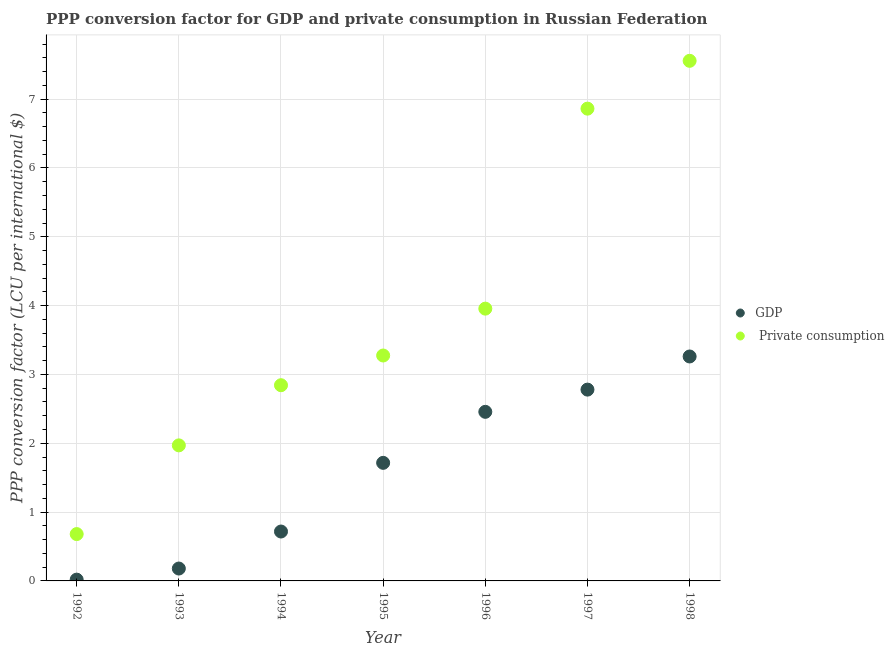How many different coloured dotlines are there?
Offer a very short reply. 2. What is the ppp conversion factor for private consumption in 1993?
Your answer should be very brief. 1.97. Across all years, what is the maximum ppp conversion factor for gdp?
Your response must be concise. 3.26. Across all years, what is the minimum ppp conversion factor for private consumption?
Make the answer very short. 0.68. In which year was the ppp conversion factor for private consumption maximum?
Your answer should be very brief. 1998. In which year was the ppp conversion factor for gdp minimum?
Provide a short and direct response. 1992. What is the total ppp conversion factor for gdp in the graph?
Offer a very short reply. 11.13. What is the difference between the ppp conversion factor for gdp in 1993 and that in 1998?
Your answer should be compact. -3.08. What is the difference between the ppp conversion factor for private consumption in 1997 and the ppp conversion factor for gdp in 1995?
Offer a terse response. 5.15. What is the average ppp conversion factor for gdp per year?
Make the answer very short. 1.59. In the year 1995, what is the difference between the ppp conversion factor for gdp and ppp conversion factor for private consumption?
Offer a very short reply. -1.56. What is the ratio of the ppp conversion factor for gdp in 1994 to that in 1998?
Keep it short and to the point. 0.22. Is the difference between the ppp conversion factor for gdp in 1992 and 1996 greater than the difference between the ppp conversion factor for private consumption in 1992 and 1996?
Offer a terse response. Yes. What is the difference between the highest and the second highest ppp conversion factor for private consumption?
Offer a terse response. 0.69. What is the difference between the highest and the lowest ppp conversion factor for private consumption?
Give a very brief answer. 6.88. Is the ppp conversion factor for private consumption strictly less than the ppp conversion factor for gdp over the years?
Your answer should be compact. No. How many dotlines are there?
Make the answer very short. 2. Does the graph contain any zero values?
Your answer should be very brief. No. Does the graph contain grids?
Make the answer very short. Yes. What is the title of the graph?
Give a very brief answer. PPP conversion factor for GDP and private consumption in Russian Federation. Does "Official aid received" appear as one of the legend labels in the graph?
Your answer should be very brief. No. What is the label or title of the Y-axis?
Your answer should be very brief. PPP conversion factor (LCU per international $). What is the PPP conversion factor (LCU per international $) in GDP in 1992?
Your response must be concise. 0.02. What is the PPP conversion factor (LCU per international $) in  Private consumption in 1992?
Your response must be concise. 0.68. What is the PPP conversion factor (LCU per international $) of GDP in 1993?
Keep it short and to the point. 0.18. What is the PPP conversion factor (LCU per international $) in  Private consumption in 1993?
Provide a succinct answer. 1.97. What is the PPP conversion factor (LCU per international $) of GDP in 1994?
Make the answer very short. 0.72. What is the PPP conversion factor (LCU per international $) in  Private consumption in 1994?
Give a very brief answer. 2.84. What is the PPP conversion factor (LCU per international $) of GDP in 1995?
Provide a succinct answer. 1.72. What is the PPP conversion factor (LCU per international $) in  Private consumption in 1995?
Offer a terse response. 3.28. What is the PPP conversion factor (LCU per international $) of GDP in 1996?
Offer a very short reply. 2.46. What is the PPP conversion factor (LCU per international $) of  Private consumption in 1996?
Offer a terse response. 3.96. What is the PPP conversion factor (LCU per international $) in GDP in 1997?
Offer a very short reply. 2.78. What is the PPP conversion factor (LCU per international $) in  Private consumption in 1997?
Your response must be concise. 6.86. What is the PPP conversion factor (LCU per international $) of GDP in 1998?
Keep it short and to the point. 3.26. What is the PPP conversion factor (LCU per international $) of  Private consumption in 1998?
Offer a terse response. 7.56. Across all years, what is the maximum PPP conversion factor (LCU per international $) of GDP?
Your answer should be very brief. 3.26. Across all years, what is the maximum PPP conversion factor (LCU per international $) of  Private consumption?
Give a very brief answer. 7.56. Across all years, what is the minimum PPP conversion factor (LCU per international $) of GDP?
Ensure brevity in your answer.  0.02. Across all years, what is the minimum PPP conversion factor (LCU per international $) of  Private consumption?
Your answer should be very brief. 0.68. What is the total PPP conversion factor (LCU per international $) in GDP in the graph?
Ensure brevity in your answer.  11.13. What is the total PPP conversion factor (LCU per international $) in  Private consumption in the graph?
Your response must be concise. 27.14. What is the difference between the PPP conversion factor (LCU per international $) of GDP in 1992 and that in 1993?
Your response must be concise. -0.16. What is the difference between the PPP conversion factor (LCU per international $) in  Private consumption in 1992 and that in 1993?
Your response must be concise. -1.29. What is the difference between the PPP conversion factor (LCU per international $) of GDP in 1992 and that in 1994?
Keep it short and to the point. -0.7. What is the difference between the PPP conversion factor (LCU per international $) in  Private consumption in 1992 and that in 1994?
Offer a very short reply. -2.16. What is the difference between the PPP conversion factor (LCU per international $) in GDP in 1992 and that in 1995?
Ensure brevity in your answer.  -1.7. What is the difference between the PPP conversion factor (LCU per international $) in  Private consumption in 1992 and that in 1995?
Provide a succinct answer. -2.59. What is the difference between the PPP conversion factor (LCU per international $) in GDP in 1992 and that in 1996?
Provide a succinct answer. -2.44. What is the difference between the PPP conversion factor (LCU per international $) in  Private consumption in 1992 and that in 1996?
Ensure brevity in your answer.  -3.28. What is the difference between the PPP conversion factor (LCU per international $) of GDP in 1992 and that in 1997?
Give a very brief answer. -2.76. What is the difference between the PPP conversion factor (LCU per international $) of  Private consumption in 1992 and that in 1997?
Offer a terse response. -6.18. What is the difference between the PPP conversion factor (LCU per international $) in GDP in 1992 and that in 1998?
Give a very brief answer. -3.24. What is the difference between the PPP conversion factor (LCU per international $) in  Private consumption in 1992 and that in 1998?
Your answer should be compact. -6.88. What is the difference between the PPP conversion factor (LCU per international $) in GDP in 1993 and that in 1994?
Your answer should be very brief. -0.54. What is the difference between the PPP conversion factor (LCU per international $) in  Private consumption in 1993 and that in 1994?
Give a very brief answer. -0.87. What is the difference between the PPP conversion factor (LCU per international $) in GDP in 1993 and that in 1995?
Give a very brief answer. -1.54. What is the difference between the PPP conversion factor (LCU per international $) of  Private consumption in 1993 and that in 1995?
Offer a very short reply. -1.31. What is the difference between the PPP conversion factor (LCU per international $) in GDP in 1993 and that in 1996?
Provide a succinct answer. -2.28. What is the difference between the PPP conversion factor (LCU per international $) of  Private consumption in 1993 and that in 1996?
Ensure brevity in your answer.  -1.99. What is the difference between the PPP conversion factor (LCU per international $) in GDP in 1993 and that in 1997?
Offer a very short reply. -2.6. What is the difference between the PPP conversion factor (LCU per international $) in  Private consumption in 1993 and that in 1997?
Your answer should be compact. -4.89. What is the difference between the PPP conversion factor (LCU per international $) in GDP in 1993 and that in 1998?
Provide a short and direct response. -3.08. What is the difference between the PPP conversion factor (LCU per international $) of  Private consumption in 1993 and that in 1998?
Your response must be concise. -5.59. What is the difference between the PPP conversion factor (LCU per international $) in GDP in 1994 and that in 1995?
Provide a short and direct response. -1. What is the difference between the PPP conversion factor (LCU per international $) of  Private consumption in 1994 and that in 1995?
Ensure brevity in your answer.  -0.43. What is the difference between the PPP conversion factor (LCU per international $) in GDP in 1994 and that in 1996?
Your answer should be very brief. -1.74. What is the difference between the PPP conversion factor (LCU per international $) of  Private consumption in 1994 and that in 1996?
Keep it short and to the point. -1.11. What is the difference between the PPP conversion factor (LCU per international $) of GDP in 1994 and that in 1997?
Ensure brevity in your answer.  -2.06. What is the difference between the PPP conversion factor (LCU per international $) of  Private consumption in 1994 and that in 1997?
Your answer should be very brief. -4.02. What is the difference between the PPP conversion factor (LCU per international $) in GDP in 1994 and that in 1998?
Your answer should be very brief. -2.54. What is the difference between the PPP conversion factor (LCU per international $) of  Private consumption in 1994 and that in 1998?
Keep it short and to the point. -4.71. What is the difference between the PPP conversion factor (LCU per international $) in GDP in 1995 and that in 1996?
Your answer should be compact. -0.74. What is the difference between the PPP conversion factor (LCU per international $) of  Private consumption in 1995 and that in 1996?
Your response must be concise. -0.68. What is the difference between the PPP conversion factor (LCU per international $) in GDP in 1995 and that in 1997?
Provide a short and direct response. -1.06. What is the difference between the PPP conversion factor (LCU per international $) in  Private consumption in 1995 and that in 1997?
Make the answer very short. -3.59. What is the difference between the PPP conversion factor (LCU per international $) of GDP in 1995 and that in 1998?
Ensure brevity in your answer.  -1.55. What is the difference between the PPP conversion factor (LCU per international $) in  Private consumption in 1995 and that in 1998?
Offer a very short reply. -4.28. What is the difference between the PPP conversion factor (LCU per international $) in GDP in 1996 and that in 1997?
Provide a short and direct response. -0.32. What is the difference between the PPP conversion factor (LCU per international $) in  Private consumption in 1996 and that in 1997?
Offer a terse response. -2.91. What is the difference between the PPP conversion factor (LCU per international $) of GDP in 1996 and that in 1998?
Offer a very short reply. -0.8. What is the difference between the PPP conversion factor (LCU per international $) in  Private consumption in 1996 and that in 1998?
Ensure brevity in your answer.  -3.6. What is the difference between the PPP conversion factor (LCU per international $) in GDP in 1997 and that in 1998?
Your answer should be compact. -0.48. What is the difference between the PPP conversion factor (LCU per international $) in  Private consumption in 1997 and that in 1998?
Your response must be concise. -0.69. What is the difference between the PPP conversion factor (LCU per international $) in GDP in 1992 and the PPP conversion factor (LCU per international $) in  Private consumption in 1993?
Give a very brief answer. -1.95. What is the difference between the PPP conversion factor (LCU per international $) of GDP in 1992 and the PPP conversion factor (LCU per international $) of  Private consumption in 1994?
Your answer should be compact. -2.82. What is the difference between the PPP conversion factor (LCU per international $) in GDP in 1992 and the PPP conversion factor (LCU per international $) in  Private consumption in 1995?
Give a very brief answer. -3.26. What is the difference between the PPP conversion factor (LCU per international $) in GDP in 1992 and the PPP conversion factor (LCU per international $) in  Private consumption in 1996?
Your answer should be compact. -3.94. What is the difference between the PPP conversion factor (LCU per international $) of GDP in 1992 and the PPP conversion factor (LCU per international $) of  Private consumption in 1997?
Your answer should be very brief. -6.84. What is the difference between the PPP conversion factor (LCU per international $) in GDP in 1992 and the PPP conversion factor (LCU per international $) in  Private consumption in 1998?
Make the answer very short. -7.54. What is the difference between the PPP conversion factor (LCU per international $) in GDP in 1993 and the PPP conversion factor (LCU per international $) in  Private consumption in 1994?
Give a very brief answer. -2.66. What is the difference between the PPP conversion factor (LCU per international $) in GDP in 1993 and the PPP conversion factor (LCU per international $) in  Private consumption in 1995?
Your answer should be compact. -3.1. What is the difference between the PPP conversion factor (LCU per international $) of GDP in 1993 and the PPP conversion factor (LCU per international $) of  Private consumption in 1996?
Provide a short and direct response. -3.78. What is the difference between the PPP conversion factor (LCU per international $) in GDP in 1993 and the PPP conversion factor (LCU per international $) in  Private consumption in 1997?
Provide a succinct answer. -6.68. What is the difference between the PPP conversion factor (LCU per international $) in GDP in 1993 and the PPP conversion factor (LCU per international $) in  Private consumption in 1998?
Offer a very short reply. -7.38. What is the difference between the PPP conversion factor (LCU per international $) in GDP in 1994 and the PPP conversion factor (LCU per international $) in  Private consumption in 1995?
Ensure brevity in your answer.  -2.56. What is the difference between the PPP conversion factor (LCU per international $) in GDP in 1994 and the PPP conversion factor (LCU per international $) in  Private consumption in 1996?
Give a very brief answer. -3.24. What is the difference between the PPP conversion factor (LCU per international $) of GDP in 1994 and the PPP conversion factor (LCU per international $) of  Private consumption in 1997?
Your response must be concise. -6.14. What is the difference between the PPP conversion factor (LCU per international $) in GDP in 1994 and the PPP conversion factor (LCU per international $) in  Private consumption in 1998?
Provide a short and direct response. -6.84. What is the difference between the PPP conversion factor (LCU per international $) of GDP in 1995 and the PPP conversion factor (LCU per international $) of  Private consumption in 1996?
Make the answer very short. -2.24. What is the difference between the PPP conversion factor (LCU per international $) in GDP in 1995 and the PPP conversion factor (LCU per international $) in  Private consumption in 1997?
Your answer should be compact. -5.15. What is the difference between the PPP conversion factor (LCU per international $) of GDP in 1995 and the PPP conversion factor (LCU per international $) of  Private consumption in 1998?
Make the answer very short. -5.84. What is the difference between the PPP conversion factor (LCU per international $) in GDP in 1996 and the PPP conversion factor (LCU per international $) in  Private consumption in 1997?
Your response must be concise. -4.41. What is the difference between the PPP conversion factor (LCU per international $) of GDP in 1996 and the PPP conversion factor (LCU per international $) of  Private consumption in 1998?
Make the answer very short. -5.1. What is the difference between the PPP conversion factor (LCU per international $) in GDP in 1997 and the PPP conversion factor (LCU per international $) in  Private consumption in 1998?
Offer a terse response. -4.78. What is the average PPP conversion factor (LCU per international $) of GDP per year?
Make the answer very short. 1.59. What is the average PPP conversion factor (LCU per international $) of  Private consumption per year?
Offer a terse response. 3.88. In the year 1992, what is the difference between the PPP conversion factor (LCU per international $) of GDP and PPP conversion factor (LCU per international $) of  Private consumption?
Ensure brevity in your answer.  -0.66. In the year 1993, what is the difference between the PPP conversion factor (LCU per international $) in GDP and PPP conversion factor (LCU per international $) in  Private consumption?
Your answer should be compact. -1.79. In the year 1994, what is the difference between the PPP conversion factor (LCU per international $) of GDP and PPP conversion factor (LCU per international $) of  Private consumption?
Ensure brevity in your answer.  -2.13. In the year 1995, what is the difference between the PPP conversion factor (LCU per international $) of GDP and PPP conversion factor (LCU per international $) of  Private consumption?
Your answer should be compact. -1.56. In the year 1996, what is the difference between the PPP conversion factor (LCU per international $) in GDP and PPP conversion factor (LCU per international $) in  Private consumption?
Your response must be concise. -1.5. In the year 1997, what is the difference between the PPP conversion factor (LCU per international $) in GDP and PPP conversion factor (LCU per international $) in  Private consumption?
Your answer should be very brief. -4.08. In the year 1998, what is the difference between the PPP conversion factor (LCU per international $) of GDP and PPP conversion factor (LCU per international $) of  Private consumption?
Your answer should be very brief. -4.3. What is the ratio of the PPP conversion factor (LCU per international $) in GDP in 1992 to that in 1993?
Provide a succinct answer. 0.1. What is the ratio of the PPP conversion factor (LCU per international $) of  Private consumption in 1992 to that in 1993?
Your response must be concise. 0.35. What is the ratio of the PPP conversion factor (LCU per international $) of GDP in 1992 to that in 1994?
Ensure brevity in your answer.  0.03. What is the ratio of the PPP conversion factor (LCU per international $) of  Private consumption in 1992 to that in 1994?
Offer a very short reply. 0.24. What is the ratio of the PPP conversion factor (LCU per international $) in GDP in 1992 to that in 1995?
Your answer should be very brief. 0.01. What is the ratio of the PPP conversion factor (LCU per international $) of  Private consumption in 1992 to that in 1995?
Keep it short and to the point. 0.21. What is the ratio of the PPP conversion factor (LCU per international $) in GDP in 1992 to that in 1996?
Ensure brevity in your answer.  0.01. What is the ratio of the PPP conversion factor (LCU per international $) of  Private consumption in 1992 to that in 1996?
Make the answer very short. 0.17. What is the ratio of the PPP conversion factor (LCU per international $) of GDP in 1992 to that in 1997?
Make the answer very short. 0.01. What is the ratio of the PPP conversion factor (LCU per international $) of  Private consumption in 1992 to that in 1997?
Your response must be concise. 0.1. What is the ratio of the PPP conversion factor (LCU per international $) in GDP in 1992 to that in 1998?
Offer a terse response. 0.01. What is the ratio of the PPP conversion factor (LCU per international $) in  Private consumption in 1992 to that in 1998?
Make the answer very short. 0.09. What is the ratio of the PPP conversion factor (LCU per international $) of GDP in 1993 to that in 1994?
Offer a terse response. 0.25. What is the ratio of the PPP conversion factor (LCU per international $) of  Private consumption in 1993 to that in 1994?
Your answer should be compact. 0.69. What is the ratio of the PPP conversion factor (LCU per international $) of GDP in 1993 to that in 1995?
Provide a short and direct response. 0.1. What is the ratio of the PPP conversion factor (LCU per international $) in  Private consumption in 1993 to that in 1995?
Your answer should be compact. 0.6. What is the ratio of the PPP conversion factor (LCU per international $) in GDP in 1993 to that in 1996?
Offer a very short reply. 0.07. What is the ratio of the PPP conversion factor (LCU per international $) of  Private consumption in 1993 to that in 1996?
Your response must be concise. 0.5. What is the ratio of the PPP conversion factor (LCU per international $) of GDP in 1993 to that in 1997?
Offer a terse response. 0.06. What is the ratio of the PPP conversion factor (LCU per international $) in  Private consumption in 1993 to that in 1997?
Offer a very short reply. 0.29. What is the ratio of the PPP conversion factor (LCU per international $) in GDP in 1993 to that in 1998?
Ensure brevity in your answer.  0.06. What is the ratio of the PPP conversion factor (LCU per international $) in  Private consumption in 1993 to that in 1998?
Provide a succinct answer. 0.26. What is the ratio of the PPP conversion factor (LCU per international $) in GDP in 1994 to that in 1995?
Your answer should be compact. 0.42. What is the ratio of the PPP conversion factor (LCU per international $) in  Private consumption in 1994 to that in 1995?
Your answer should be compact. 0.87. What is the ratio of the PPP conversion factor (LCU per international $) of GDP in 1994 to that in 1996?
Provide a short and direct response. 0.29. What is the ratio of the PPP conversion factor (LCU per international $) of  Private consumption in 1994 to that in 1996?
Your answer should be compact. 0.72. What is the ratio of the PPP conversion factor (LCU per international $) in GDP in 1994 to that in 1997?
Ensure brevity in your answer.  0.26. What is the ratio of the PPP conversion factor (LCU per international $) of  Private consumption in 1994 to that in 1997?
Make the answer very short. 0.41. What is the ratio of the PPP conversion factor (LCU per international $) of GDP in 1994 to that in 1998?
Keep it short and to the point. 0.22. What is the ratio of the PPP conversion factor (LCU per international $) in  Private consumption in 1994 to that in 1998?
Your answer should be compact. 0.38. What is the ratio of the PPP conversion factor (LCU per international $) of GDP in 1995 to that in 1996?
Keep it short and to the point. 0.7. What is the ratio of the PPP conversion factor (LCU per international $) of  Private consumption in 1995 to that in 1996?
Give a very brief answer. 0.83. What is the ratio of the PPP conversion factor (LCU per international $) in GDP in 1995 to that in 1997?
Offer a terse response. 0.62. What is the ratio of the PPP conversion factor (LCU per international $) in  Private consumption in 1995 to that in 1997?
Provide a short and direct response. 0.48. What is the ratio of the PPP conversion factor (LCU per international $) in GDP in 1995 to that in 1998?
Provide a short and direct response. 0.53. What is the ratio of the PPP conversion factor (LCU per international $) in  Private consumption in 1995 to that in 1998?
Give a very brief answer. 0.43. What is the ratio of the PPP conversion factor (LCU per international $) of GDP in 1996 to that in 1997?
Your response must be concise. 0.88. What is the ratio of the PPP conversion factor (LCU per international $) in  Private consumption in 1996 to that in 1997?
Keep it short and to the point. 0.58. What is the ratio of the PPP conversion factor (LCU per international $) in GDP in 1996 to that in 1998?
Provide a short and direct response. 0.75. What is the ratio of the PPP conversion factor (LCU per international $) of  Private consumption in 1996 to that in 1998?
Provide a succinct answer. 0.52. What is the ratio of the PPP conversion factor (LCU per international $) in GDP in 1997 to that in 1998?
Offer a very short reply. 0.85. What is the ratio of the PPP conversion factor (LCU per international $) of  Private consumption in 1997 to that in 1998?
Keep it short and to the point. 0.91. What is the difference between the highest and the second highest PPP conversion factor (LCU per international $) of GDP?
Ensure brevity in your answer.  0.48. What is the difference between the highest and the second highest PPP conversion factor (LCU per international $) in  Private consumption?
Provide a succinct answer. 0.69. What is the difference between the highest and the lowest PPP conversion factor (LCU per international $) of GDP?
Make the answer very short. 3.24. What is the difference between the highest and the lowest PPP conversion factor (LCU per international $) of  Private consumption?
Give a very brief answer. 6.88. 